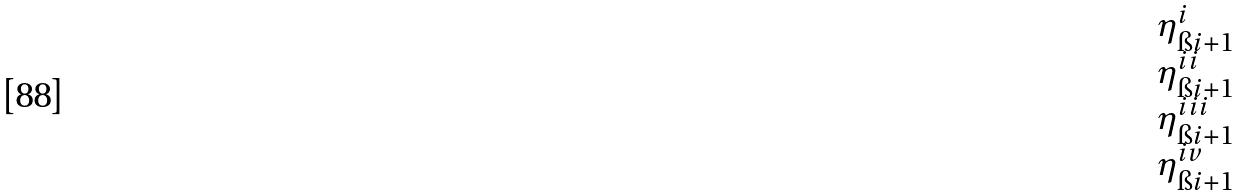<formula> <loc_0><loc_0><loc_500><loc_500>\begin{matrix} \eta ^ { i } _ { \i i + 1 } \\ \eta ^ { i i } _ { \i i + 1 } \\ \eta ^ { i i i } _ { \i i + 1 } \\ \eta ^ { i v } _ { \i i + 1 } \end{matrix}</formula> 